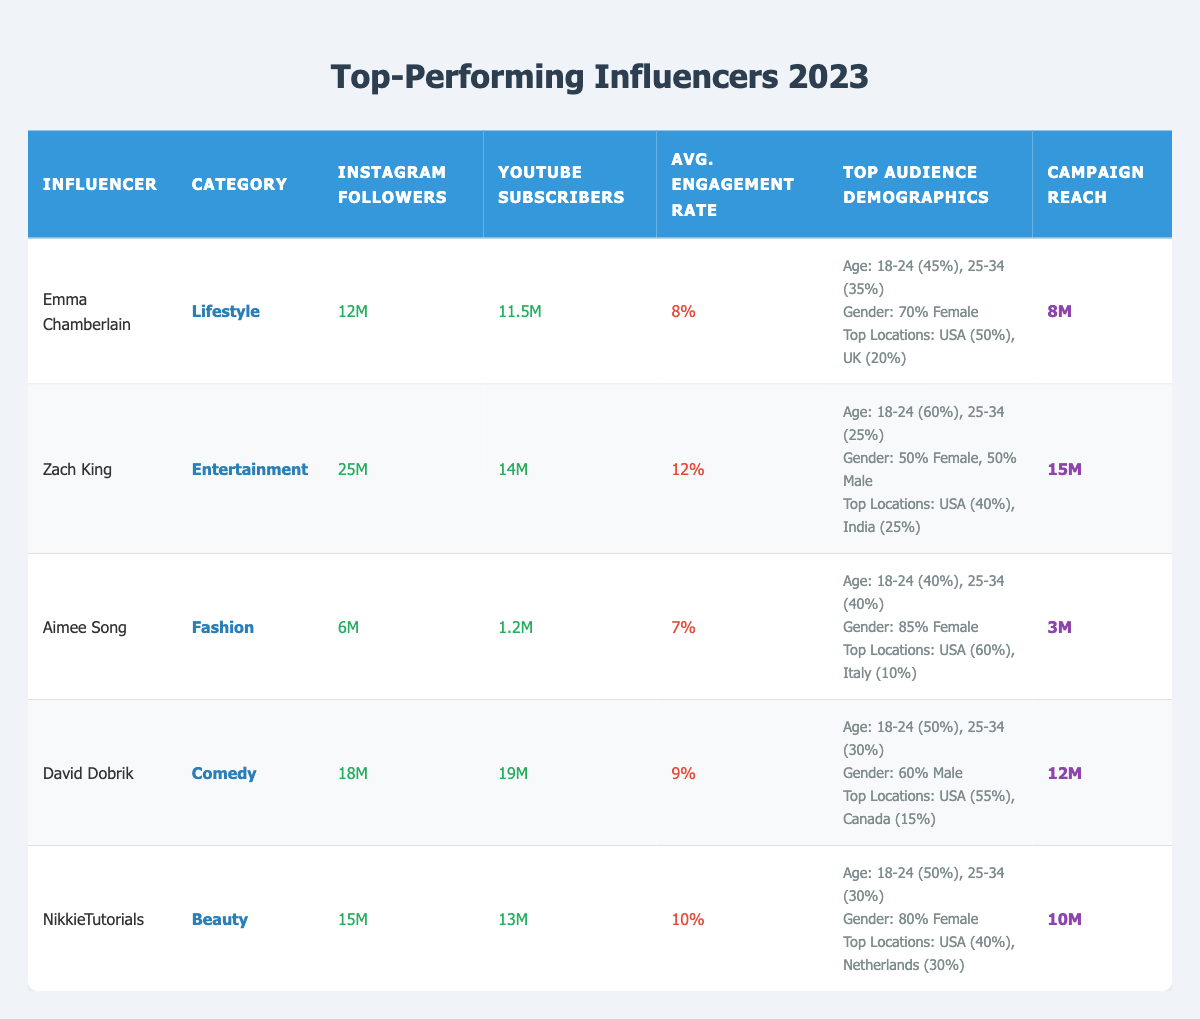What is the average engagement rate of the influencers listed? The engagement rates given are 8%, 12%, 7%, 9%, and 10%. To find the average, add those values: (8 + 12 + 7 + 9 + 10) = 46, then divide by the number of influencers (5): 46/5 = 9.2%.
Answer: 9.2% Which influencer has the highest number of Instagram followers? The Instagram followers for the influencers are 12M, 25M, 6M, 18M, and 15M. The highest value is 25M from Zach King.
Answer: Zach King Is the majority of Emma Chamberlain's audience female? Emma Chamberlain's audience demographic shows 70% female and 30% male. Since 70% is greater than 50%, it indicates that the majority is female.
Answer: Yes What is the total campaign reach of all the influencers combined? The campaign reach values for the influencers are 8M, 15M, 3M, 12M, and 10M. Adding them gives (8 + 15 + 3 + 12 + 10) = 48M.
Answer: 48M Which influencer has the lowest number of YouTube subscribers? The YouTube subscriber counts are 11.5M, 14M, 1.2M, 19M, and 13M. The lowest is 1.2M from Aimee Song.
Answer: Aimee Song What percentage of Zach King's audience is aged 25-34? The age distribution for Zach King indicates that 25% of his audience is aged 25-34.
Answer: 25% Out of the influencers listed, who has the highest campaign reach, and how much is it? Comparing the campaign reaches: 8M, 15M, 3M, 12M, and 10M. The highest is 15M from Zach King.
Answer: Zach King, 15M Which category has the most diverse gender distribution? Zach King's audience is split evenly (50% female and 50% male). All others have a notable majority in either gender, thus indicating the most diverse gender distribution.
Answer: Zach King If we combine the Instagram followers of Emma Chamberlain and David Dobrik, how many do they have together? Their counts are 12M for Emma and 18M for David. Adding these gives (12 + 18) = 30M.
Answer: 30M Is Aimee Song's top audience demographic majority male? Aimee Song's audience demographic shows that 85% is female and 15% is male, indicating the majority is female, not male.
Answer: No 